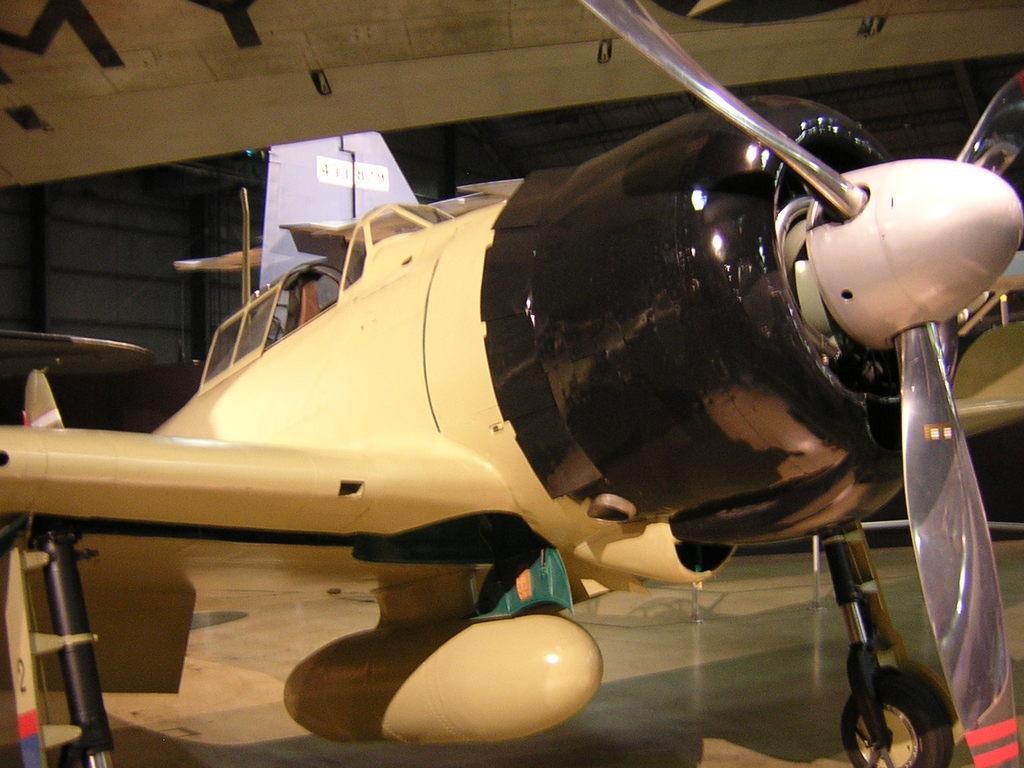Please provide a concise description of this image. In this picture I can see an aircraft in the middle, in the background it looks like a shirt. 